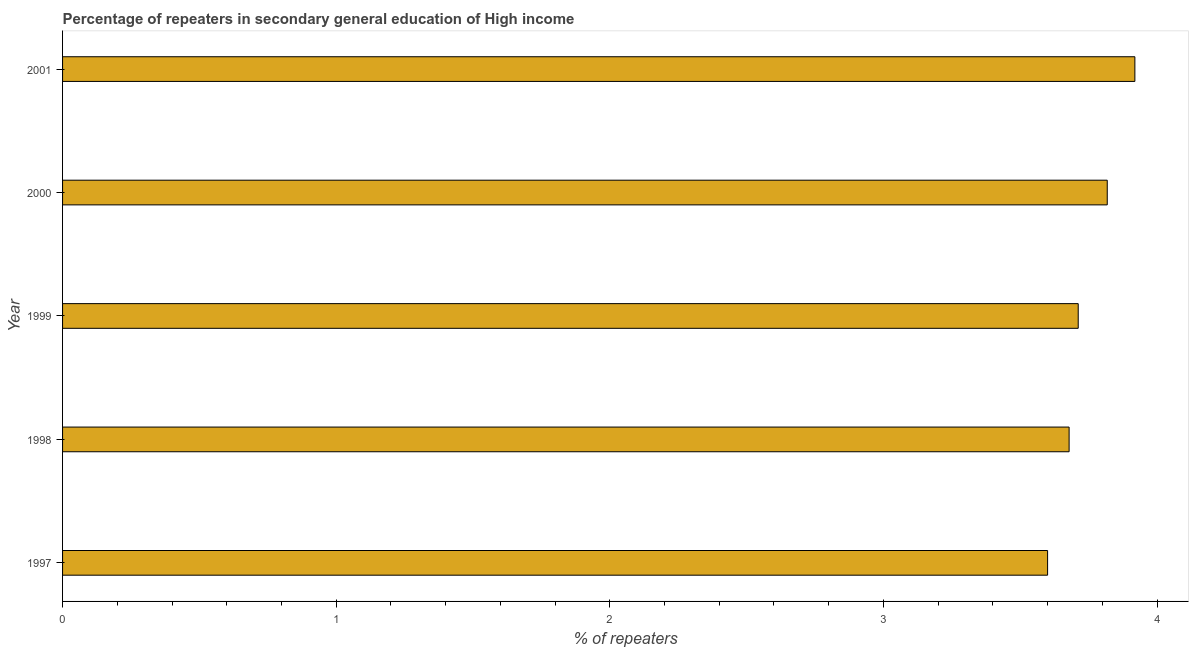Does the graph contain grids?
Keep it short and to the point. No. What is the title of the graph?
Give a very brief answer. Percentage of repeaters in secondary general education of High income. What is the label or title of the X-axis?
Your response must be concise. % of repeaters. What is the percentage of repeaters in 1998?
Make the answer very short. 3.68. Across all years, what is the maximum percentage of repeaters?
Keep it short and to the point. 3.92. Across all years, what is the minimum percentage of repeaters?
Provide a short and direct response. 3.6. In which year was the percentage of repeaters maximum?
Provide a succinct answer. 2001. What is the sum of the percentage of repeaters?
Provide a short and direct response. 18.73. What is the difference between the percentage of repeaters in 1998 and 1999?
Offer a very short reply. -0.03. What is the average percentage of repeaters per year?
Provide a succinct answer. 3.75. What is the median percentage of repeaters?
Provide a succinct answer. 3.71. In how many years, is the percentage of repeaters greater than 3.6 %?
Offer a terse response. 5. What is the ratio of the percentage of repeaters in 1997 to that in 2000?
Your answer should be very brief. 0.94. What is the difference between the highest and the second highest percentage of repeaters?
Your answer should be very brief. 0.1. Is the sum of the percentage of repeaters in 1997 and 1999 greater than the maximum percentage of repeaters across all years?
Offer a terse response. Yes. What is the difference between the highest and the lowest percentage of repeaters?
Provide a short and direct response. 0.32. In how many years, is the percentage of repeaters greater than the average percentage of repeaters taken over all years?
Make the answer very short. 2. Are all the bars in the graph horizontal?
Provide a short and direct response. Yes. How many years are there in the graph?
Keep it short and to the point. 5. Are the values on the major ticks of X-axis written in scientific E-notation?
Your answer should be compact. No. What is the % of repeaters in 1997?
Your answer should be compact. 3.6. What is the % of repeaters of 1998?
Provide a short and direct response. 3.68. What is the % of repeaters of 1999?
Your response must be concise. 3.71. What is the % of repeaters of 2000?
Provide a short and direct response. 3.82. What is the % of repeaters in 2001?
Your answer should be compact. 3.92. What is the difference between the % of repeaters in 1997 and 1998?
Keep it short and to the point. -0.08. What is the difference between the % of repeaters in 1997 and 1999?
Your response must be concise. -0.11. What is the difference between the % of repeaters in 1997 and 2000?
Make the answer very short. -0.22. What is the difference between the % of repeaters in 1997 and 2001?
Your response must be concise. -0.32. What is the difference between the % of repeaters in 1998 and 1999?
Provide a short and direct response. -0.03. What is the difference between the % of repeaters in 1998 and 2000?
Your answer should be compact. -0.14. What is the difference between the % of repeaters in 1998 and 2001?
Keep it short and to the point. -0.24. What is the difference between the % of repeaters in 1999 and 2000?
Keep it short and to the point. -0.11. What is the difference between the % of repeaters in 1999 and 2001?
Give a very brief answer. -0.21. What is the difference between the % of repeaters in 2000 and 2001?
Offer a very short reply. -0.1. What is the ratio of the % of repeaters in 1997 to that in 2000?
Your answer should be compact. 0.94. What is the ratio of the % of repeaters in 1997 to that in 2001?
Provide a short and direct response. 0.92. What is the ratio of the % of repeaters in 1998 to that in 2000?
Offer a terse response. 0.96. What is the ratio of the % of repeaters in 1998 to that in 2001?
Provide a succinct answer. 0.94. What is the ratio of the % of repeaters in 1999 to that in 2001?
Ensure brevity in your answer.  0.95. What is the ratio of the % of repeaters in 2000 to that in 2001?
Offer a very short reply. 0.97. 